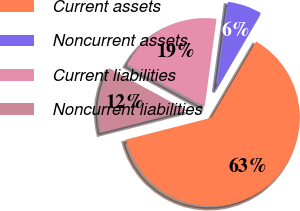Convert chart. <chart><loc_0><loc_0><loc_500><loc_500><pie_chart><fcel>Current assets<fcel>Noncurrent assets<fcel>Current liabilities<fcel>Noncurrent liabilities<nl><fcel>62.6%<fcel>6.28%<fcel>19.21%<fcel>11.91%<nl></chart> 